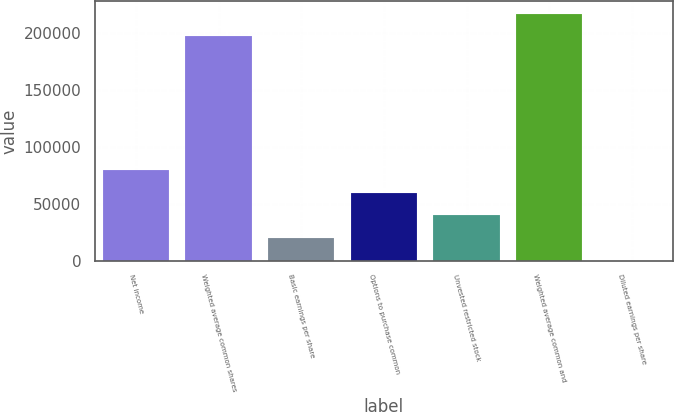<chart> <loc_0><loc_0><loc_500><loc_500><bar_chart><fcel>Net income<fcel>Weighted average common shares<fcel>Basic earnings per share<fcel>Options to purchase common<fcel>Unvested restricted stock<fcel>Weighted average common and<fcel>Diluted earnings per share<nl><fcel>79340.6<fcel>196703<fcel>19835.4<fcel>59505.6<fcel>39670.5<fcel>216538<fcel>0.37<nl></chart> 